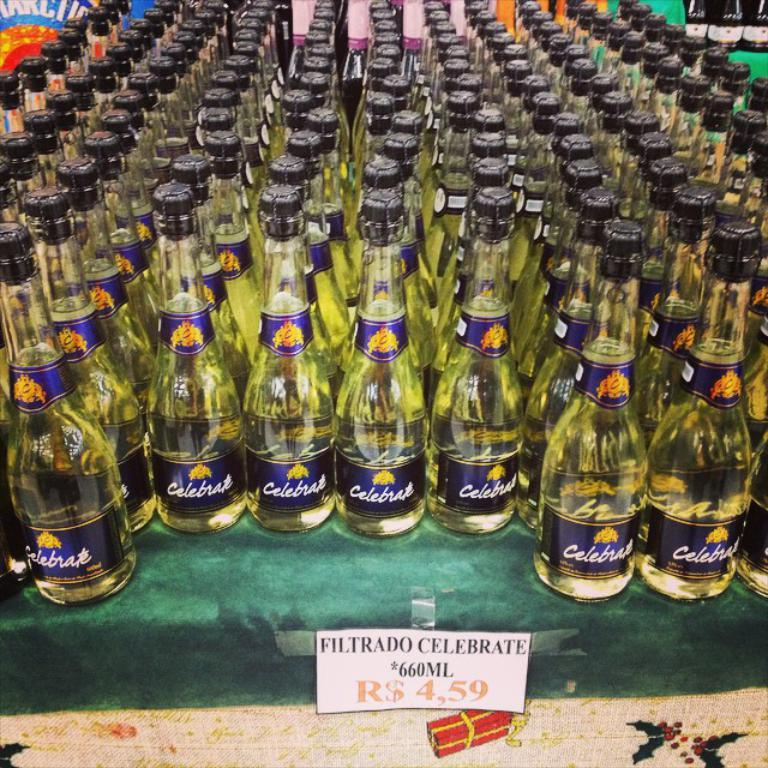<image>
Summarize the visual content of the image. Many bottles of Celebrate are on display in a store. 